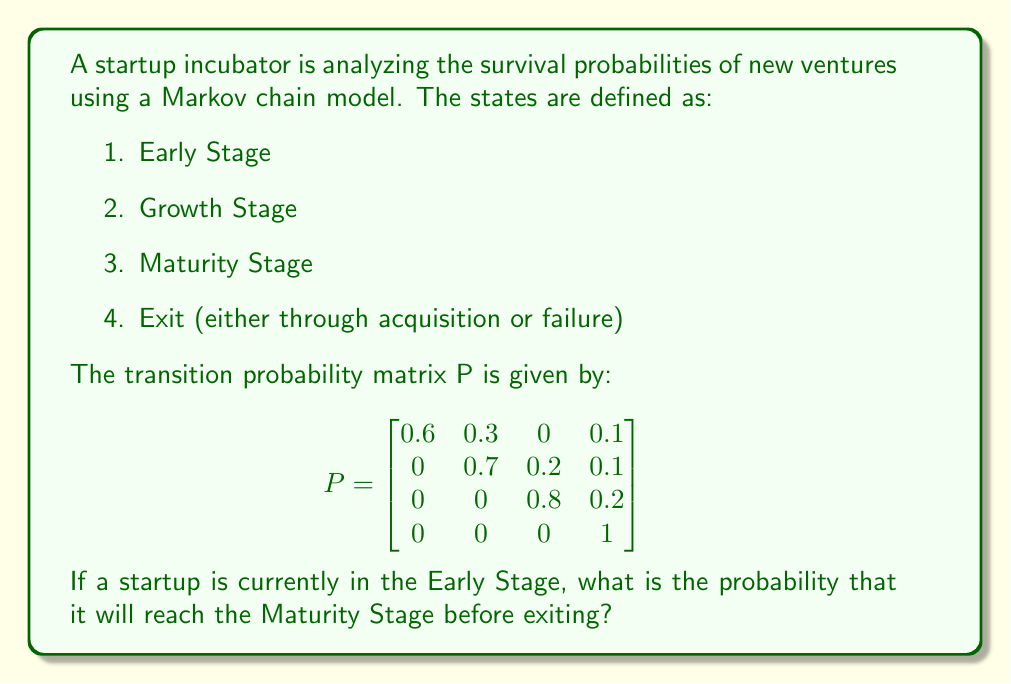Teach me how to tackle this problem. To solve this problem, we need to use the concept of absorption probabilities in Markov chains. We're interested in the probability of reaching the Maturity Stage (state 3) before being absorbed by the Exit state (state 4), starting from the Early Stage (state 1).

Step 1: Identify the transient states and the absorbing states.
Transient states: 1 (Early Stage), 2 (Growth Stage), 3 (Maturity Stage)
Absorbing state: 4 (Exit)

Step 2: Create the matrix Q of transition probabilities between transient states.

$$Q = \begin{bmatrix}
0.6 & 0.3 & 0 \\
0 & 0.7 & 0.2 \\
0 & 0 & 0.8
\end{bmatrix}$$

Step 3: Calculate $(I - Q)^{-1}$, where I is the 3x3 identity matrix.

$$I - Q = \begin{bmatrix}
0.4 & -0.3 & 0 \\
0 & 0.3 & -0.2 \\
0 & 0 & 0.2
\end{bmatrix}$$

$$(I - Q)^{-1} = \begin{bmatrix}
2.5 & 2.5 & 2.5 \\
0 & 3.33333 & 3.33333 \\
0 & 0 & 5
\end{bmatrix}$$

Step 4: The probability of reaching state 3 (Maturity Stage) from state 1 (Early Stage) before being absorbed is given by the element in the first row, third column of $(I - Q)^{-1}$.

This probability is 2.5 or 0.5 when expressed as a decimal.
Answer: 0.5 